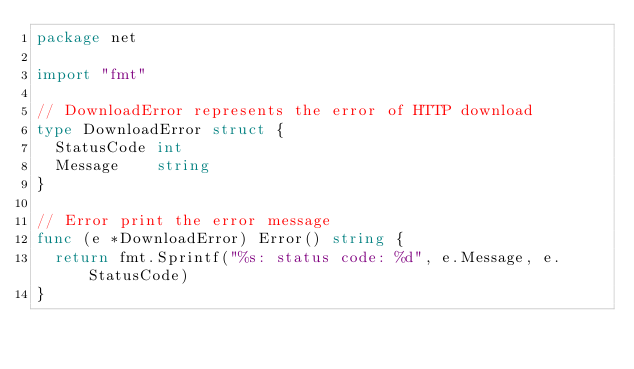Convert code to text. <code><loc_0><loc_0><loc_500><loc_500><_Go_>package net

import "fmt"

// DownloadError represents the error of HTTP download
type DownloadError struct {
	StatusCode int
	Message    string
}

// Error print the error message
func (e *DownloadError) Error() string {
	return fmt.Sprintf("%s: status code: %d", e.Message, e.StatusCode)
}
</code> 